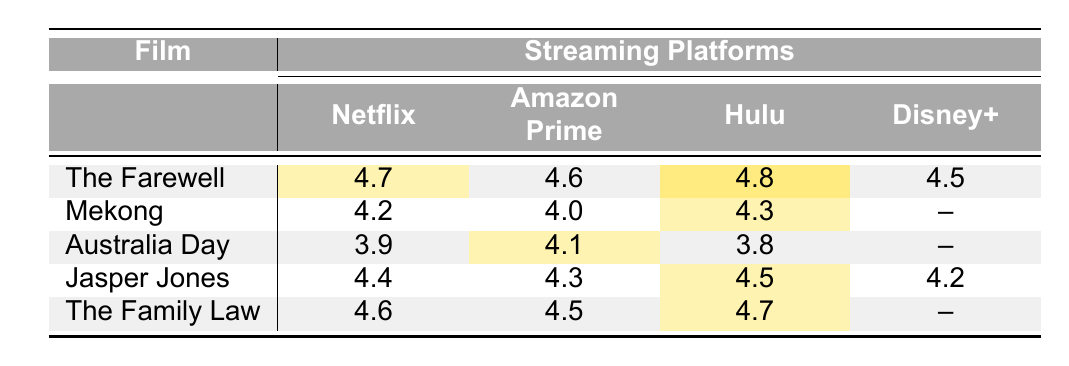What is the highest audience rating for "The Farewell"? Looking at the row for "The Farewell," the ratings across the platforms are 4.7 (Netflix), 4.6 (Amazon Prime), 4.8 (Hulu), and 4.5 (Disney+). The highest rating is 4.8 on Hulu.
Answer: 4.8 Which platform has the lowest rating for "Australia Day"? Reviewing the ratings for "Australia Day," the values are 3.9 (Netflix), 4.1 (Amazon Prime), 3.8 (Hulu), and no rating for Disney+. The lowest rating is 3.8 from Hulu.
Answer: Hulu What is the average rating of "Jasper Jones" across all available platforms? The ratings for "Jasper Jones" are 4.4 (Netflix), 4.3 (Amazon Prime), 4.5 (Hulu), and 4.2 (Disney+). Adding them gives 4.4 + 4.3 + 4.5 + 4.2 = 17.4. There are 4 platforms, so the average is 17.4 / 4 = 4.35.
Answer: 4.35 Do all films have audience ratings on Disney+? The films with ratings for Disney+ are "Jasper Jones" (4.2) and "The Farewell" (4.5). However, "Mekong," "Australia Day," and "The Family Law" do not have ratings on this platform. Thus, not all films have ratings on Disney+.
Answer: No Which film has the highest average rating across the platforms where it is available? First, calculate the average ratings for each film. "The Farewell" is (4.7 + 4.6 + 4.8 + 4.5) / 4 = 4.65. "Mekong" is (4.2 + 4.0 + 4.3) / 3 = 4.17. "Australia Day" is (3.9 + 4.1 + 3.8) / 3 = 3.93. "Jasper Jones" is (4.4 + 4.3 + 4.5 + 4.2) / 4 = 4.35. "The Family Law" is (4.6 + 4.5 + 4.7) / 3 = 4.53. Comparing the averages, "The Farewell" has the highest average rating of 4.65.
Answer: The Farewell Which film has the most consistent rating across streaming platforms? Evaluating the standard deviation for each film's ratings where applicable: "The Farewell" has ratings of 4.7, 4.6, 4.8, and 4.5 (low variation), "Mekong" has 4.2, 4.0, 4.3 (moderate), "Australia Day" has 3.9, 4.1, 3.8 (moderate), "Jasper Jones" has 4.4, 4.3, 4.5, and 4.2 (low), with "The Family Law" having 4.6, 4.5, and 4.7 (low). The Farewell has the narrowest range (0.3), indicating it has the most consistent rating.
Answer: The Farewell 